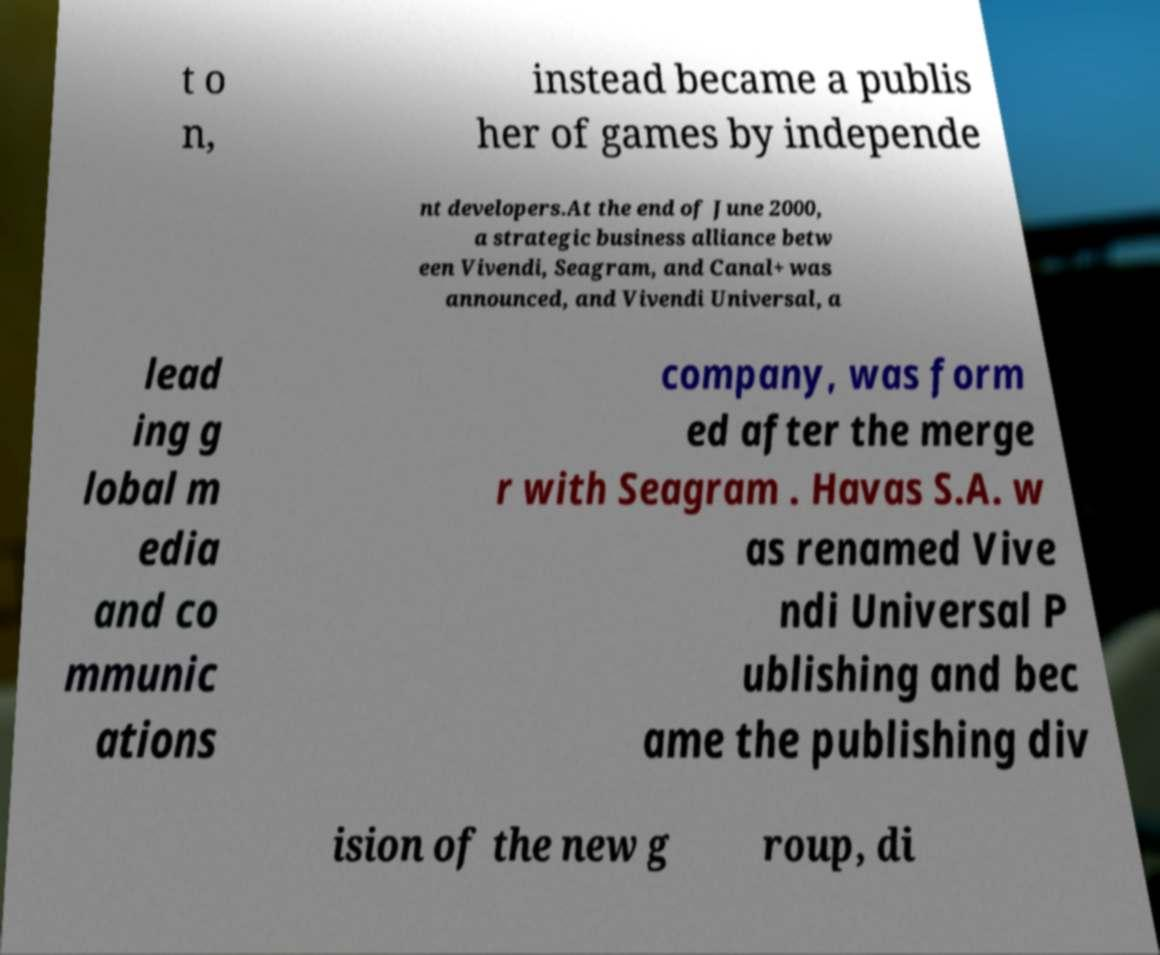Please identify and transcribe the text found in this image. t o n, instead became a publis her of games by independe nt developers.At the end of June 2000, a strategic business alliance betw een Vivendi, Seagram, and Canal+ was announced, and Vivendi Universal, a lead ing g lobal m edia and co mmunic ations company, was form ed after the merge r with Seagram . Havas S.A. w as renamed Vive ndi Universal P ublishing and bec ame the publishing div ision of the new g roup, di 